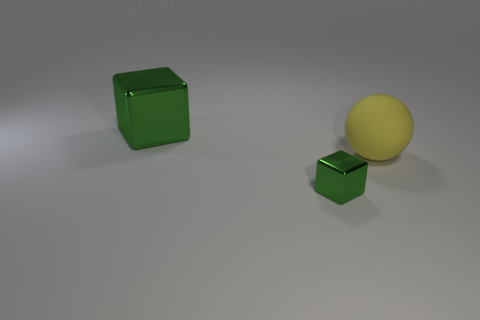The small green thing that is made of the same material as the big green object is what shape?
Offer a very short reply. Cube. Is there any other thing that is the same shape as the yellow object?
Provide a succinct answer. No. There is a shiny block in front of the metal thing that is left of the block in front of the big yellow matte object; what is its color?
Provide a succinct answer. Green. Are there fewer big things that are behind the sphere than things behind the tiny cube?
Your response must be concise. Yes. Do the large green object and the small green thing have the same shape?
Offer a terse response. Yes. What number of green blocks have the same size as the yellow rubber thing?
Offer a terse response. 1. Are there fewer tiny green metallic cubes left of the small block than large gray matte spheres?
Offer a very short reply. No. How big is the yellow matte object behind the green metallic block that is in front of the big yellow matte sphere?
Offer a very short reply. Large. What number of objects are tiny yellow metallic cylinders or green metal cubes?
Keep it short and to the point. 2. Are there any big metal things that have the same color as the small shiny cube?
Give a very brief answer. Yes. 